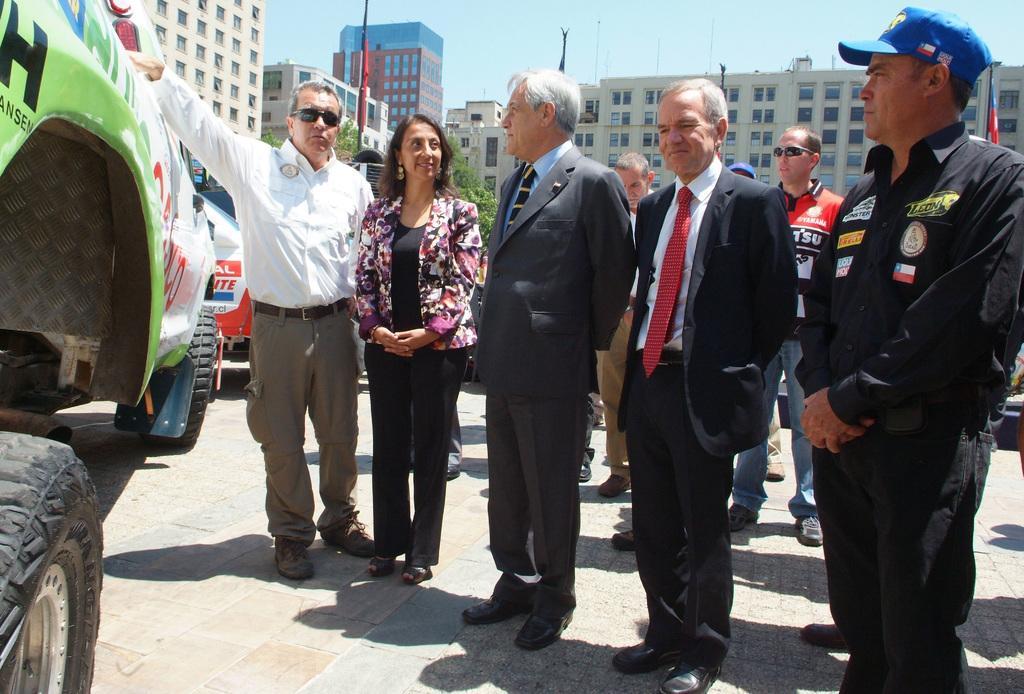In one or two sentences, can you explain what this image depicts? In the foreground of the picture there are group of people and a vehicle. In the middle of the picture there are buildings, trees, poles, flags, vehicle and other objects. At the top it is sky. 